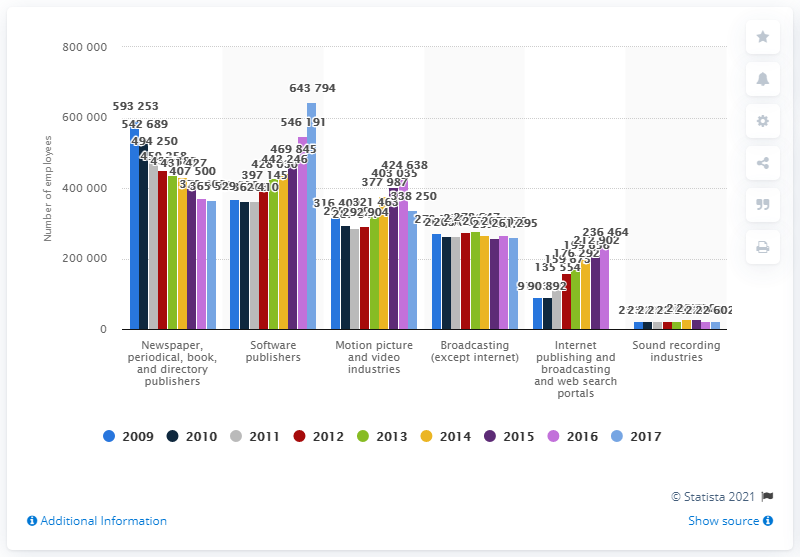List a handful of essential elements in this visual. In 2017, a total of 643,794 people were employed in the motion picture and video industries. In 2017, there were approximately 643,794 people employed by software publishers. 